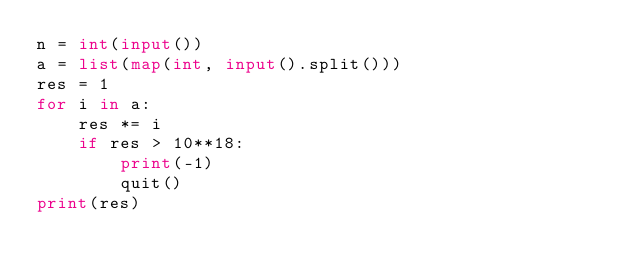<code> <loc_0><loc_0><loc_500><loc_500><_Python_>n = int(input())
a = list(map(int, input().split()))
res = 1
for i in a:
    res *= i
    if res > 10**18:
        print(-1)
        quit()
print(res)</code> 